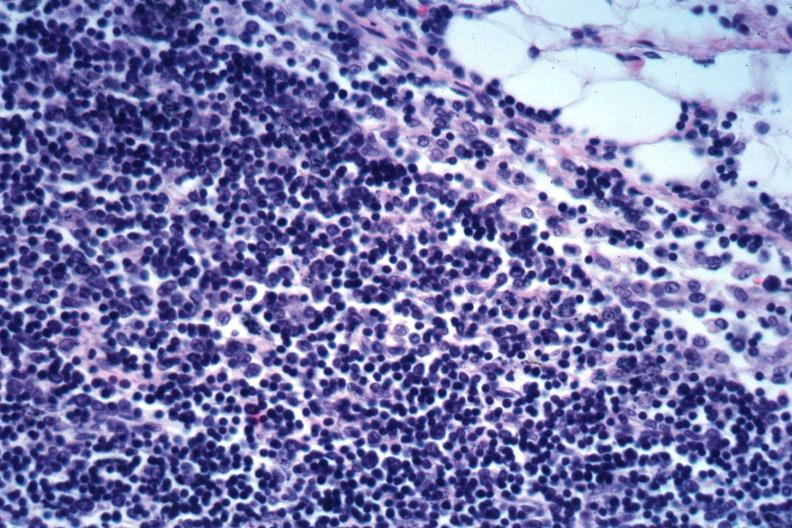how does this image show edge of node?
Answer the question using a single word or phrase. With infiltration capsule obliteration subcapsular sinus mixture small dark lymphocytes and larger cells with vesicular nuclei not specified 